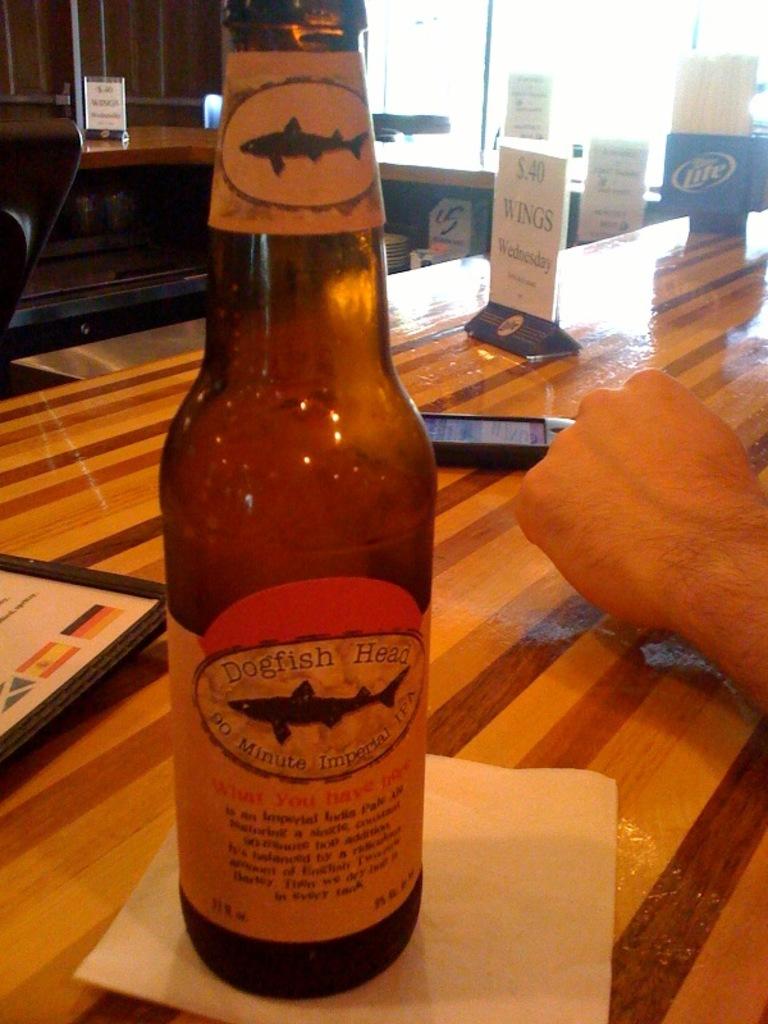What brand of beer is this?
Make the answer very short. Dogfish head. 